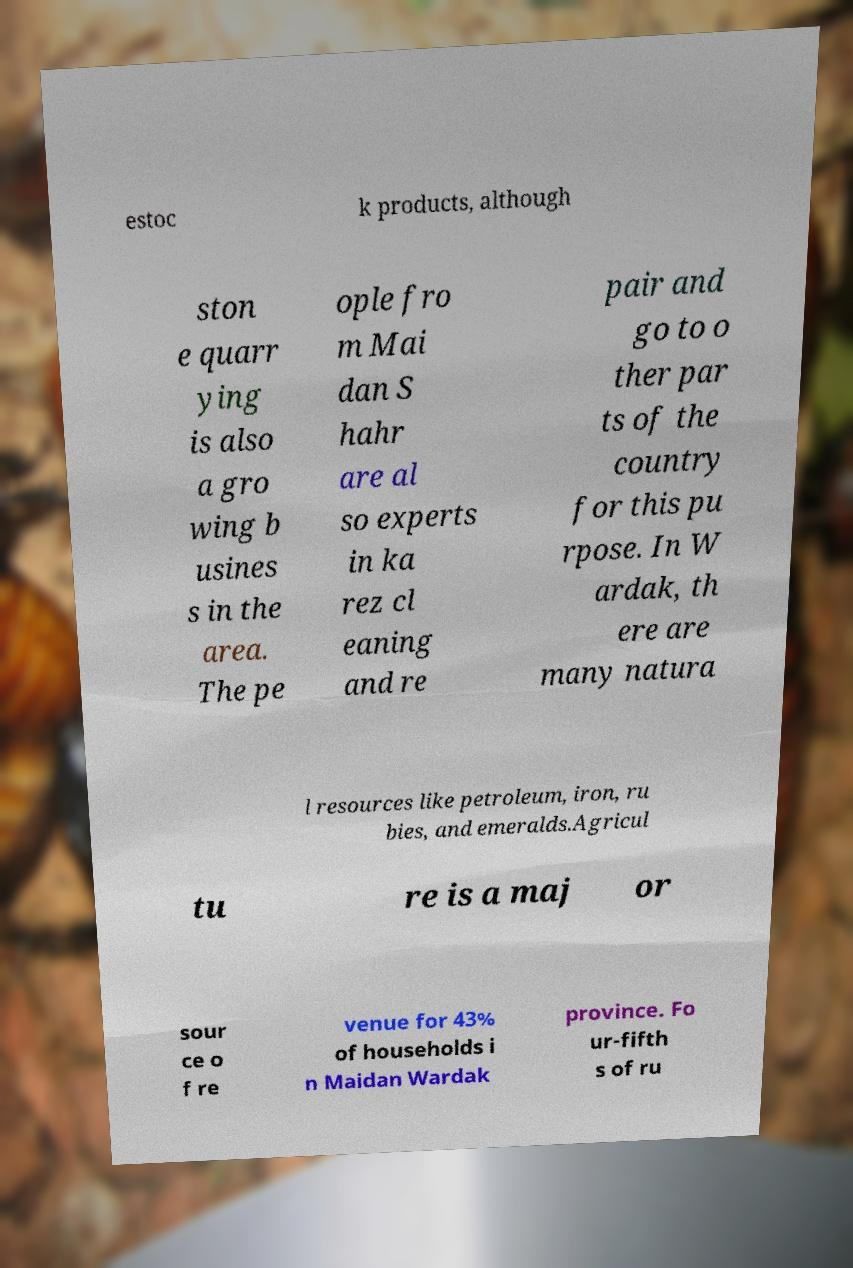There's text embedded in this image that I need extracted. Can you transcribe it verbatim? estoc k products, although ston e quarr ying is also a gro wing b usines s in the area. The pe ople fro m Mai dan S hahr are al so experts in ka rez cl eaning and re pair and go to o ther par ts of the country for this pu rpose. In W ardak, th ere are many natura l resources like petroleum, iron, ru bies, and emeralds.Agricul tu re is a maj or sour ce o f re venue for 43% of households i n Maidan Wardak province. Fo ur-fifth s of ru 